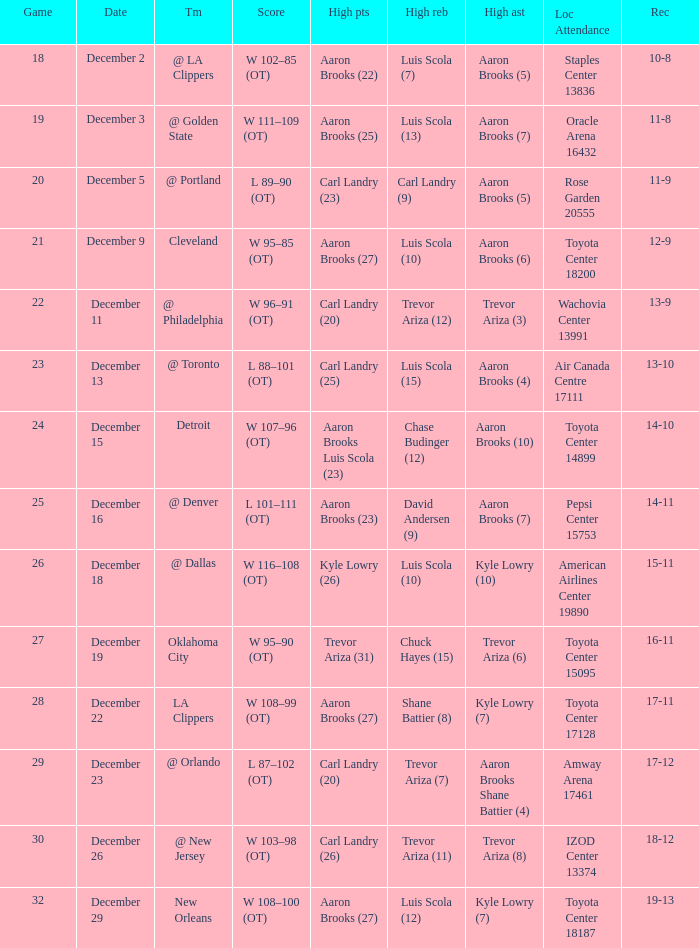Where was the game in which Carl Landry (25) did the most high points played? Air Canada Centre 17111. 